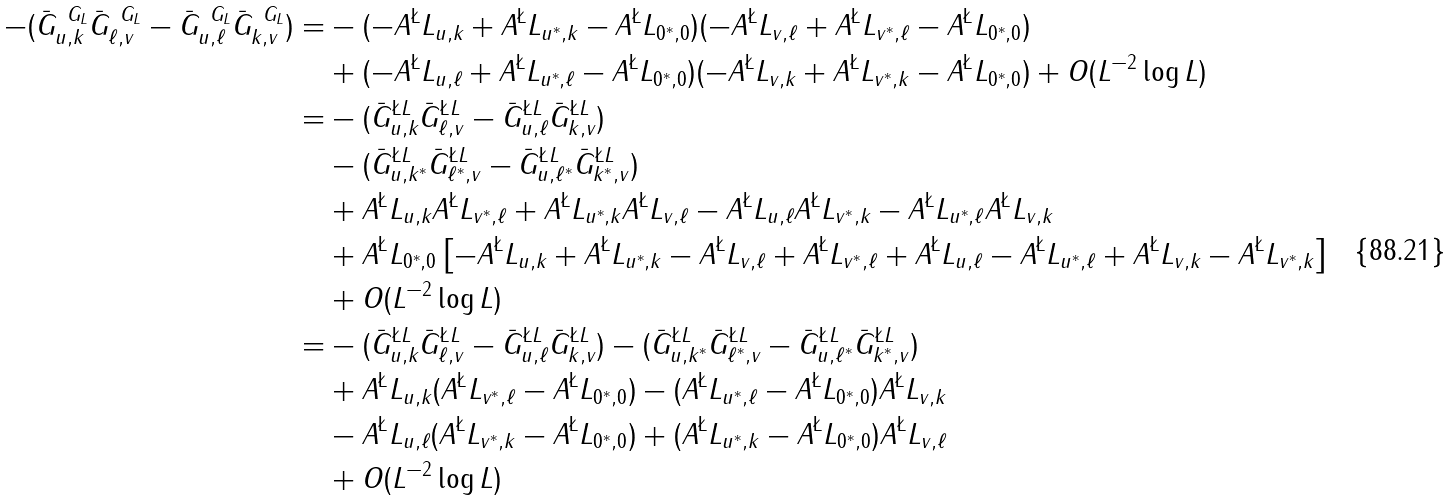<formula> <loc_0><loc_0><loc_500><loc_500>- ( \bar { G } ^ { \ G _ { L } } _ { u , k } \bar { G } ^ { \ G _ { L } } _ { \ell , v } - \bar { G } ^ { \ G _ { L } } _ { u , \ell } \bar { G } ^ { \ G _ { L } } _ { k , v } ) = & - ( - A ^ { \L } L _ { u , k } + A ^ { \L } L _ { u ^ { * } , k } - A ^ { \L } L _ { 0 ^ { * } , 0 } ) ( - A ^ { \L } L _ { v , \ell } + A ^ { \L } L _ { v ^ { * } , \ell } - A ^ { \L } L _ { 0 ^ { * } , 0 } ) \\ & + ( - A ^ { \L } L _ { u , \ell } + A ^ { \L } L _ { u ^ { * } , \ell } - A ^ { \L } L _ { 0 ^ { * } , 0 } ) ( - A ^ { \L } L _ { v , k } + A ^ { \L } L _ { v ^ { * } , k } - A ^ { \L } L _ { 0 ^ { * } , 0 } ) + O ( L ^ { - 2 } \log L ) \\ = & - ( \bar { G } ^ { \L L } _ { u , k } \bar { G } ^ { \L L } _ { \ell , v } - \bar { G } ^ { \L L } _ { u , \ell } \bar { G } ^ { \L L } _ { k , v } ) \\ & - ( \bar { G } ^ { \L L } _ { u , k ^ { * } } \bar { G } ^ { \L L } _ { \ell ^ { * } , v } - \bar { G } ^ { \L L } _ { u , \ell ^ { * } } \bar { G } ^ { \L L } _ { k ^ { * } , v } ) \\ & + A ^ { \L } L _ { u , k } A ^ { \L } L _ { v ^ { * } , \ell } + A ^ { \L } L _ { u ^ { * } , k } A ^ { \L } L _ { v , \ell } - A ^ { \L } L _ { u , \ell } A ^ { \L } L _ { v ^ { * } , k } - A ^ { \L } L _ { u ^ { * } , \ell } A ^ { \L } L _ { v , k } \\ & + A ^ { \L } L _ { 0 ^ { * } , 0 } \left [ - A ^ { \L } L _ { u , k } + A ^ { \L } L _ { u ^ { * } , k } - A ^ { \L } L _ { v , \ell } + A ^ { \L } L _ { v ^ { * } , \ell } + A ^ { \L } L _ { u , \ell } - A ^ { \L } L _ { u ^ { * } , \ell } + A ^ { \L } L _ { v , k } - A ^ { \L } L _ { v ^ { * } , k } \right ] \\ & + O ( L ^ { - 2 } \log L ) \\ = & - ( \bar { G } ^ { \L L } _ { u , k } \bar { G } ^ { \L L } _ { \ell , v } - \bar { G } ^ { \L L } _ { u , \ell } \bar { G } ^ { \L L } _ { k , v } ) - ( \bar { G } ^ { \L L } _ { u , k ^ { * } } \bar { G } ^ { \L L } _ { \ell ^ { * } , v } - \bar { G } ^ { \L L } _ { u , \ell ^ { * } } \bar { G } ^ { \L L } _ { k ^ { * } , v } ) \\ & + A ^ { \L } L _ { u , k } ( A ^ { \L } L _ { v ^ { * } , \ell } - A ^ { \L } L _ { 0 ^ { * } , 0 } ) - ( A ^ { \L } L _ { u ^ { * } , \ell } - A ^ { \L } L _ { 0 ^ { * } , 0 } ) A ^ { \L } L _ { v , k } \\ & - A ^ { \L } L _ { u , \ell } ( A ^ { \L } L _ { v ^ { * } , k } - A ^ { \L } L _ { 0 ^ { * } , 0 } ) + ( A ^ { \L } L _ { u ^ { * } , k } - A ^ { \L } L _ { 0 ^ { * } , 0 } ) A ^ { \L } L _ { v , \ell } \\ & + O ( L ^ { - 2 } \log L )</formula> 